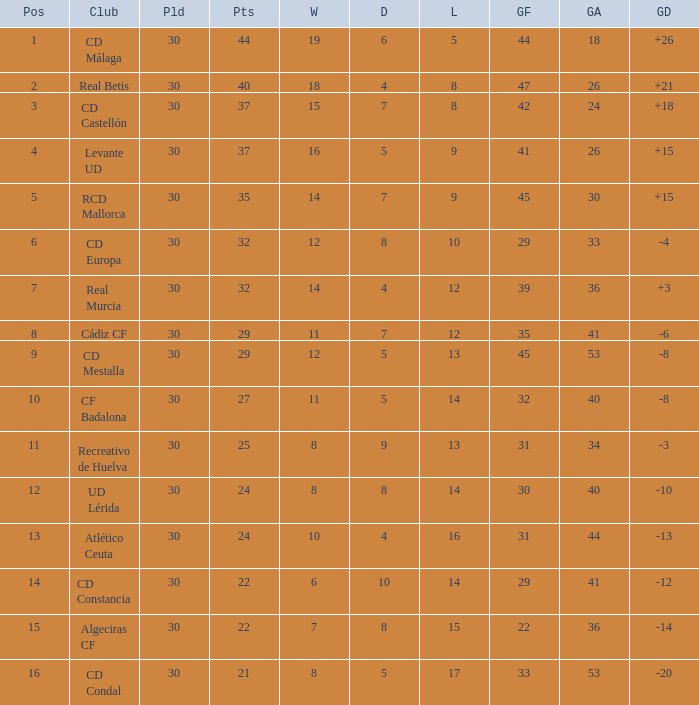What is the wins number when the points were smaller than 27, and goals against was 41? 6.0. 